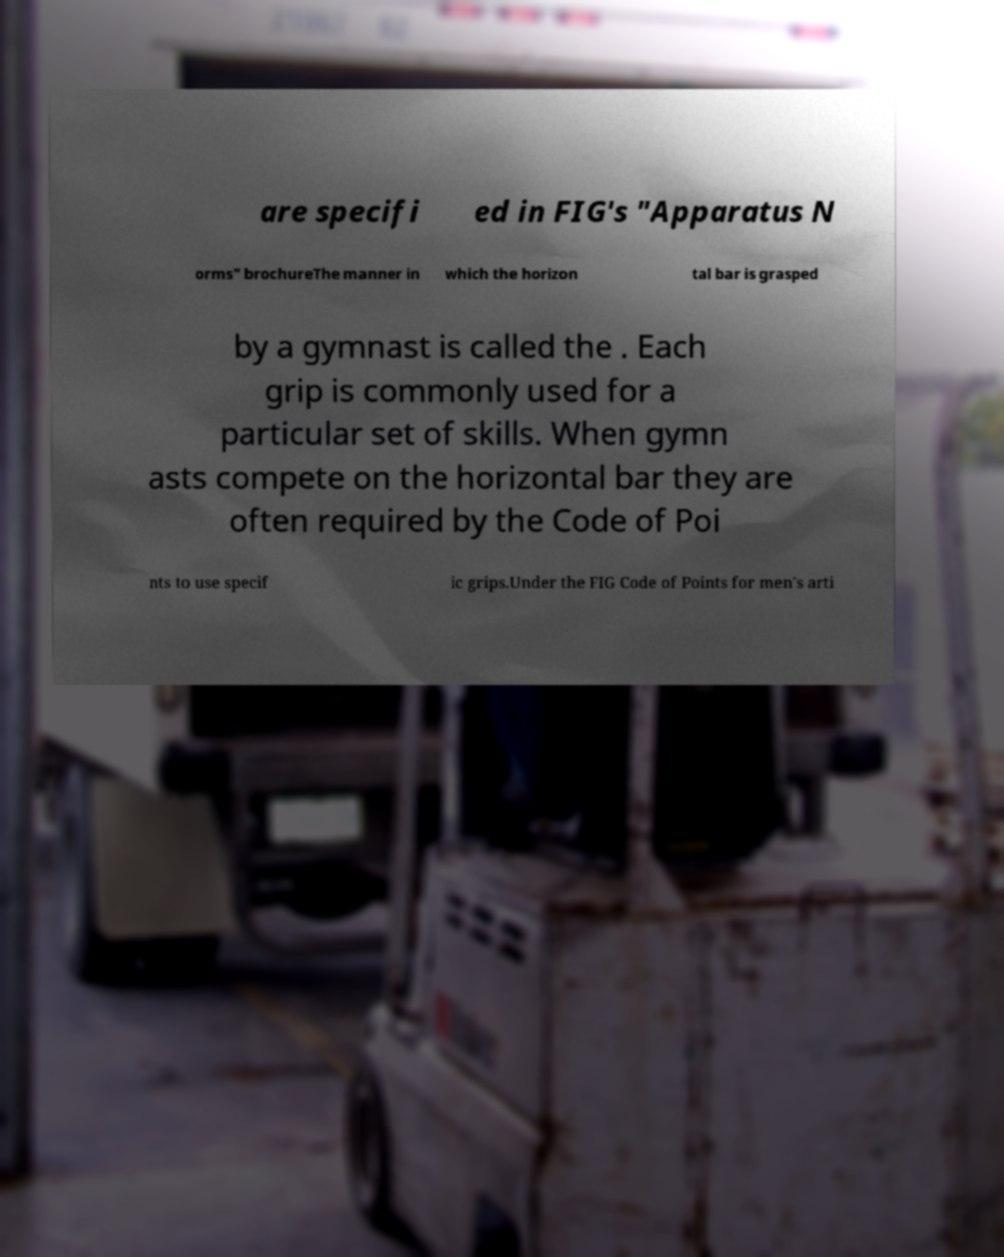There's text embedded in this image that I need extracted. Can you transcribe it verbatim? are specifi ed in FIG's "Apparatus N orms" brochureThe manner in which the horizon tal bar is grasped by a gymnast is called the . Each grip is commonly used for a particular set of skills. When gymn asts compete on the horizontal bar they are often required by the Code of Poi nts to use specif ic grips.Under the FIG Code of Points for men's arti 